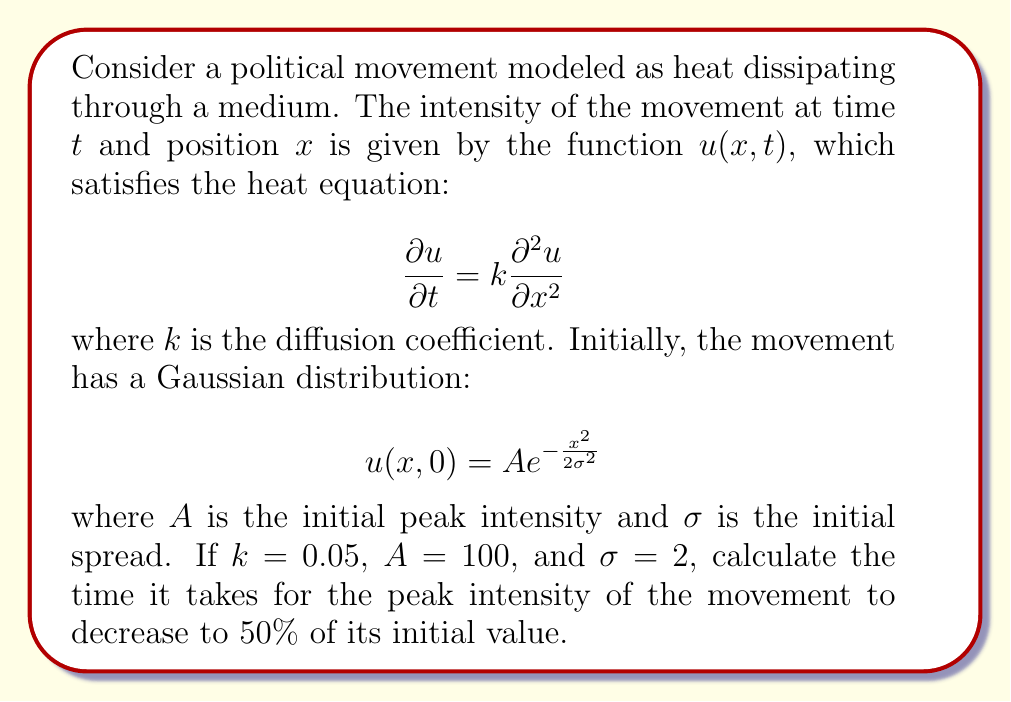Provide a solution to this math problem. To solve this problem, we need to follow these steps:

1) The solution to the heat equation with a Gaussian initial condition is:

   $$u(x,t) = \frac{A\sigma}{\sqrt{\sigma^2 + 2kt}} e^{-\frac{x^2}{2(\sigma^2 + 2kt)}}$$

2) The peak intensity occurs at $x = 0$ for all $t$, so we're interested in:

   $$u(0,t) = \frac{A\sigma}{\sqrt{\sigma^2 + 2kt}}$$

3) We want to find $t$ when $u(0,t) = 0.5A$. Let's set up this equation:

   $$\frac{A\sigma}{\sqrt{\sigma^2 + 2kt}} = 0.5A$$

4) Simplify by dividing both sides by $A$:

   $$\frac{\sigma}{\sqrt{\sigma^2 + 2kt}} = 0.5$$

5) Square both sides:

   $$\frac{\sigma^2}{\sigma^2 + 2kt} = 0.25$$

6) Multiply both sides by $(\sigma^2 + 2kt)$:

   $$\sigma^2 = 0.25(\sigma^2 + 2kt)$$

7) Expand the right side:

   $$\sigma^2 = 0.25\sigma^2 + 0.5kt$$

8) Subtract $0.25\sigma^2$ from both sides:

   $$0.75\sigma^2 = 0.5kt$$

9) Divide both sides by $0.5k$:

   $$\frac{1.5\sigma^2}{k} = t$$

10) Now substitute the given values: $k = 0.05$, $\sigma = 2$:

    $$t = \frac{1.5 \cdot 2^2}{0.05} = \frac{6}{0.05} = 120$$

Therefore, it takes 120 time units for the peak intensity to decrease to 50% of its initial value.
Answer: 120 time units 